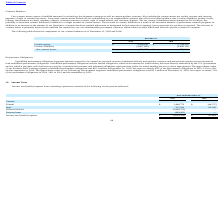According to Luna Innovations Incorporated's financial document, What do contract assets consist of? unbilled amounts for technology development contracts as well as custom product contracts.. The document states: "Our contract assets consist of unbilled amounts for technology development contracts as well as custom product contracts. Also included in contract as..." Also, can you calculate: What is the change in Contract assets between December 31, 2018 and 2019? Based on the calculation: 3,208,206-2,759,315, the result is 448891. This is based on the information: "Contract assets $ 3,208,206 $ 2,759,315 Contract assets $ 3,208,206 $ 2,759,315..." The key data points involved are: 2,759,315, 3,208,206. Also, can you calculate: What is the average Contract assets for December 31, 2018 and 2019? To answer this question, I need to perform calculations using the financial data. The calculation is: (3,208,206+2,759,315) / 2, which equals 2983760.5. This is based on the information: "Contract assets $ 3,208,206 $ 2,759,315 Contract assets $ 3,208,206 $ 2,759,315..." The key data points involved are: 2,759,315, 3,208,206. Additionally, In which year were contract assets less than 3,000,000? According to the financial document, 2018. The relevant text states: "2019 2018..." Also, What was the contract liabilities in 2019 and 2018 respectively? The document shows two values: (3,887,685) and (2,486,111). From the document: "Contract liabilities (3,887,685) (2,486,111) Contract liabilities (3,887,685) (2,486,111)..." Also, What was the change in net contract (liabilities)/assets? According to the financial document, $1.0 million. The relevant text states: ". The net contract (liabilities)/assets changed by $1.0 million, due primarily to increased contract liabilities in addition to a slight increase in contract asset..." 